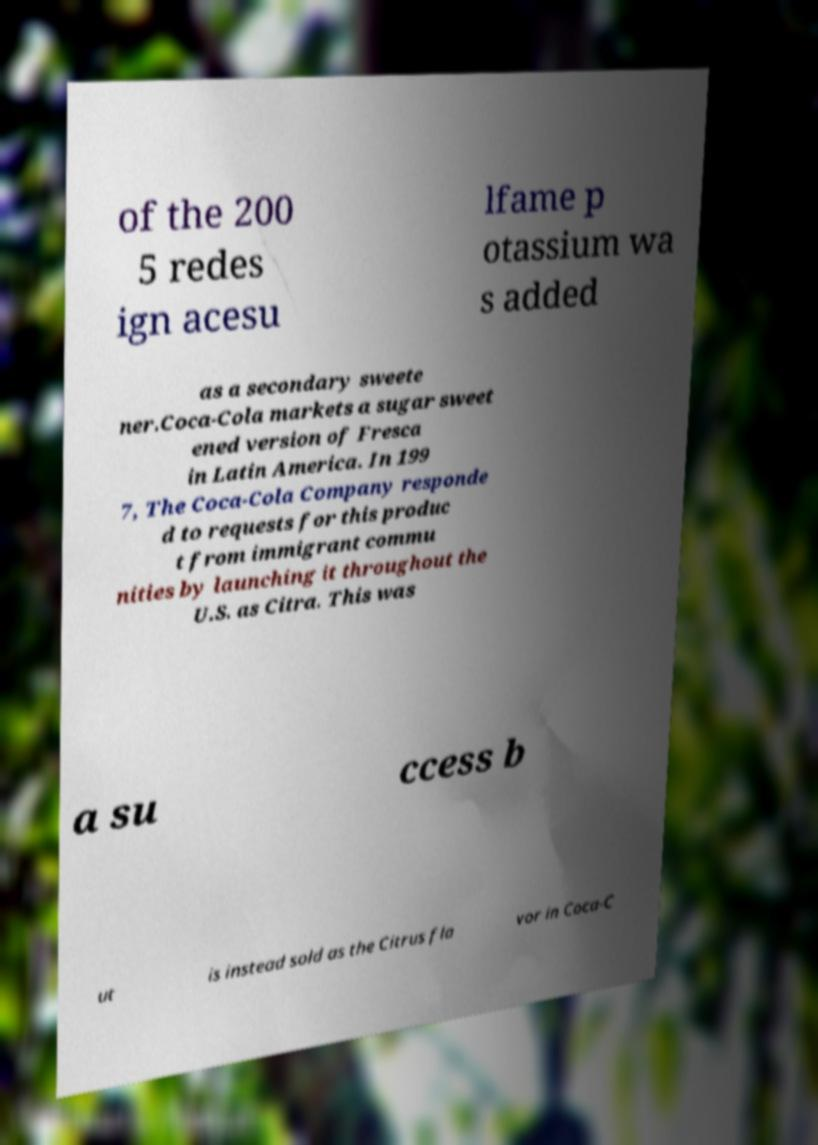Can you read and provide the text displayed in the image?This photo seems to have some interesting text. Can you extract and type it out for me? of the 200 5 redes ign acesu lfame p otassium wa s added as a secondary sweete ner.Coca-Cola markets a sugar sweet ened version of Fresca in Latin America. In 199 7, The Coca-Cola Company responde d to requests for this produc t from immigrant commu nities by launching it throughout the U.S. as Citra. This was a su ccess b ut is instead sold as the Citrus fla vor in Coca-C 